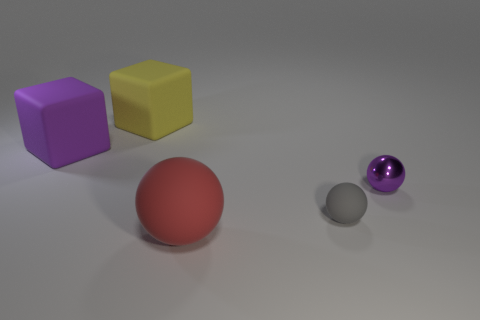How many large red objects are the same material as the tiny purple ball?
Your answer should be very brief. 0. Is the number of tiny objects that are right of the small rubber object greater than the number of large red metal objects?
Make the answer very short. Yes. Are there any small purple metal objects of the same shape as the gray rubber thing?
Ensure brevity in your answer.  Yes. How many things are big rubber spheres or small purple balls?
Provide a succinct answer. 2. There is a purple thing that is left of the big thing that is in front of the gray sphere; how many tiny purple spheres are on the right side of it?
Your answer should be compact. 1. What material is the purple thing that is the same shape as the gray rubber thing?
Give a very brief answer. Metal. There is a thing that is in front of the purple matte thing and behind the gray object; what material is it?
Make the answer very short. Metal. Is the number of small purple metallic spheres that are behind the purple metallic sphere less than the number of tiny objects that are in front of the big red sphere?
Provide a succinct answer. No. How many other objects are the same size as the yellow block?
Provide a short and direct response. 2. The rubber thing right of the thing that is in front of the rubber object on the right side of the big red ball is what shape?
Provide a short and direct response. Sphere. 